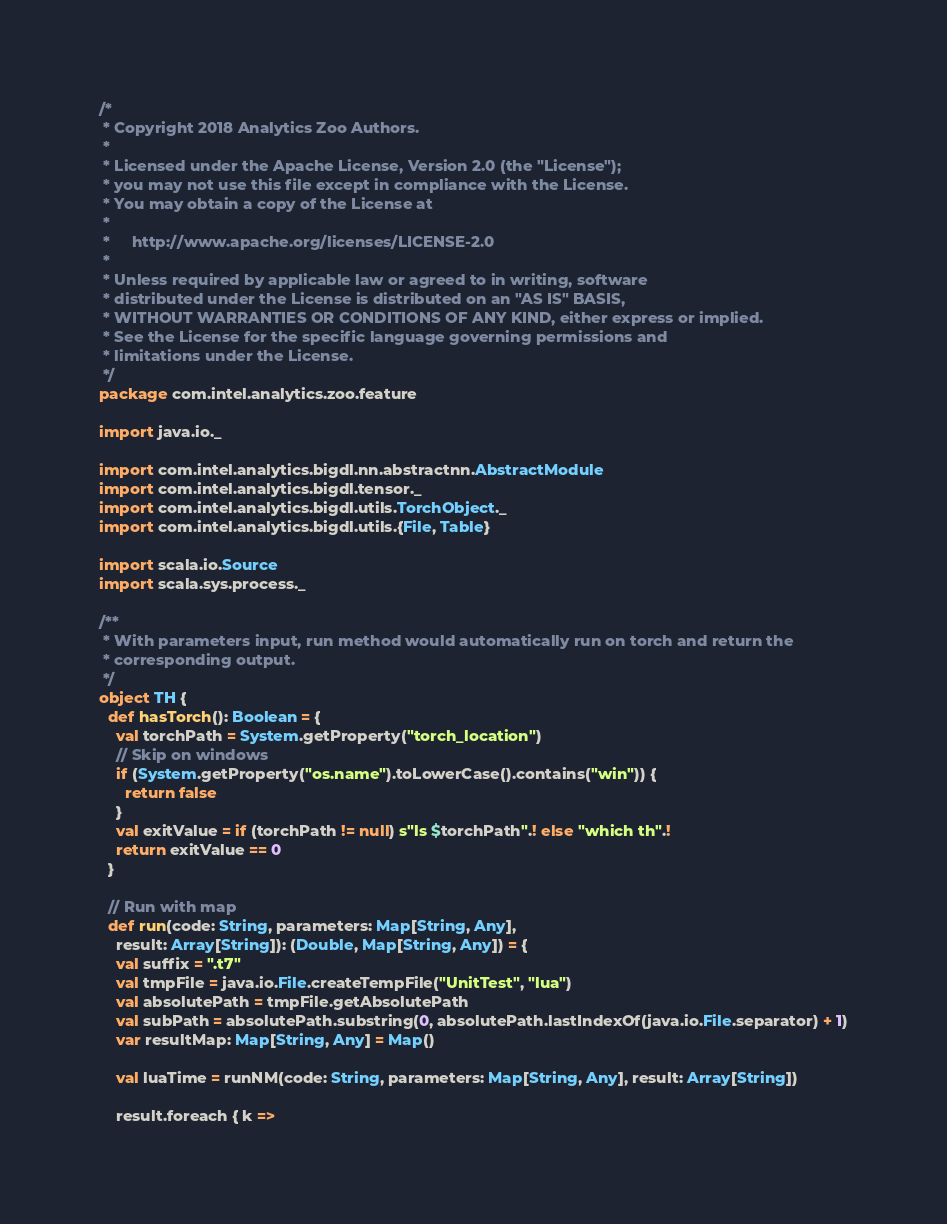Convert code to text. <code><loc_0><loc_0><loc_500><loc_500><_Scala_>/*
 * Copyright 2018 Analytics Zoo Authors.
 *
 * Licensed under the Apache License, Version 2.0 (the "License");
 * you may not use this file except in compliance with the License.
 * You may obtain a copy of the License at
 *
 *     http://www.apache.org/licenses/LICENSE-2.0
 *
 * Unless required by applicable law or agreed to in writing, software
 * distributed under the License is distributed on an "AS IS" BASIS,
 * WITHOUT WARRANTIES OR CONDITIONS OF ANY KIND, either express or implied.
 * See the License for the specific language governing permissions and
 * limitations under the License.
 */
package com.intel.analytics.zoo.feature

import java.io._

import com.intel.analytics.bigdl.nn.abstractnn.AbstractModule
import com.intel.analytics.bigdl.tensor._
import com.intel.analytics.bigdl.utils.TorchObject._
import com.intel.analytics.bigdl.utils.{File, Table}

import scala.io.Source
import scala.sys.process._

/**
 * With parameters input, run method would automatically run on torch and return the
 * corresponding output.
 */
object TH {
  def hasTorch(): Boolean = {
    val torchPath = System.getProperty("torch_location")
    // Skip on windows
    if (System.getProperty("os.name").toLowerCase().contains("win")) {
      return false
    }
    val exitValue = if (torchPath != null) s"ls $torchPath".! else "which th".!
    return exitValue == 0
  }

  // Run with map
  def run(code: String, parameters: Map[String, Any],
    result: Array[String]): (Double, Map[String, Any]) = {
    val suffix = ".t7"
    val tmpFile = java.io.File.createTempFile("UnitTest", "lua")
    val absolutePath = tmpFile.getAbsolutePath
    val subPath = absolutePath.substring(0, absolutePath.lastIndexOf(java.io.File.separator) + 1)
    var resultMap: Map[String, Any] = Map()

    val luaTime = runNM(code: String, parameters: Map[String, Any], result: Array[String])

    result.foreach { k =></code> 